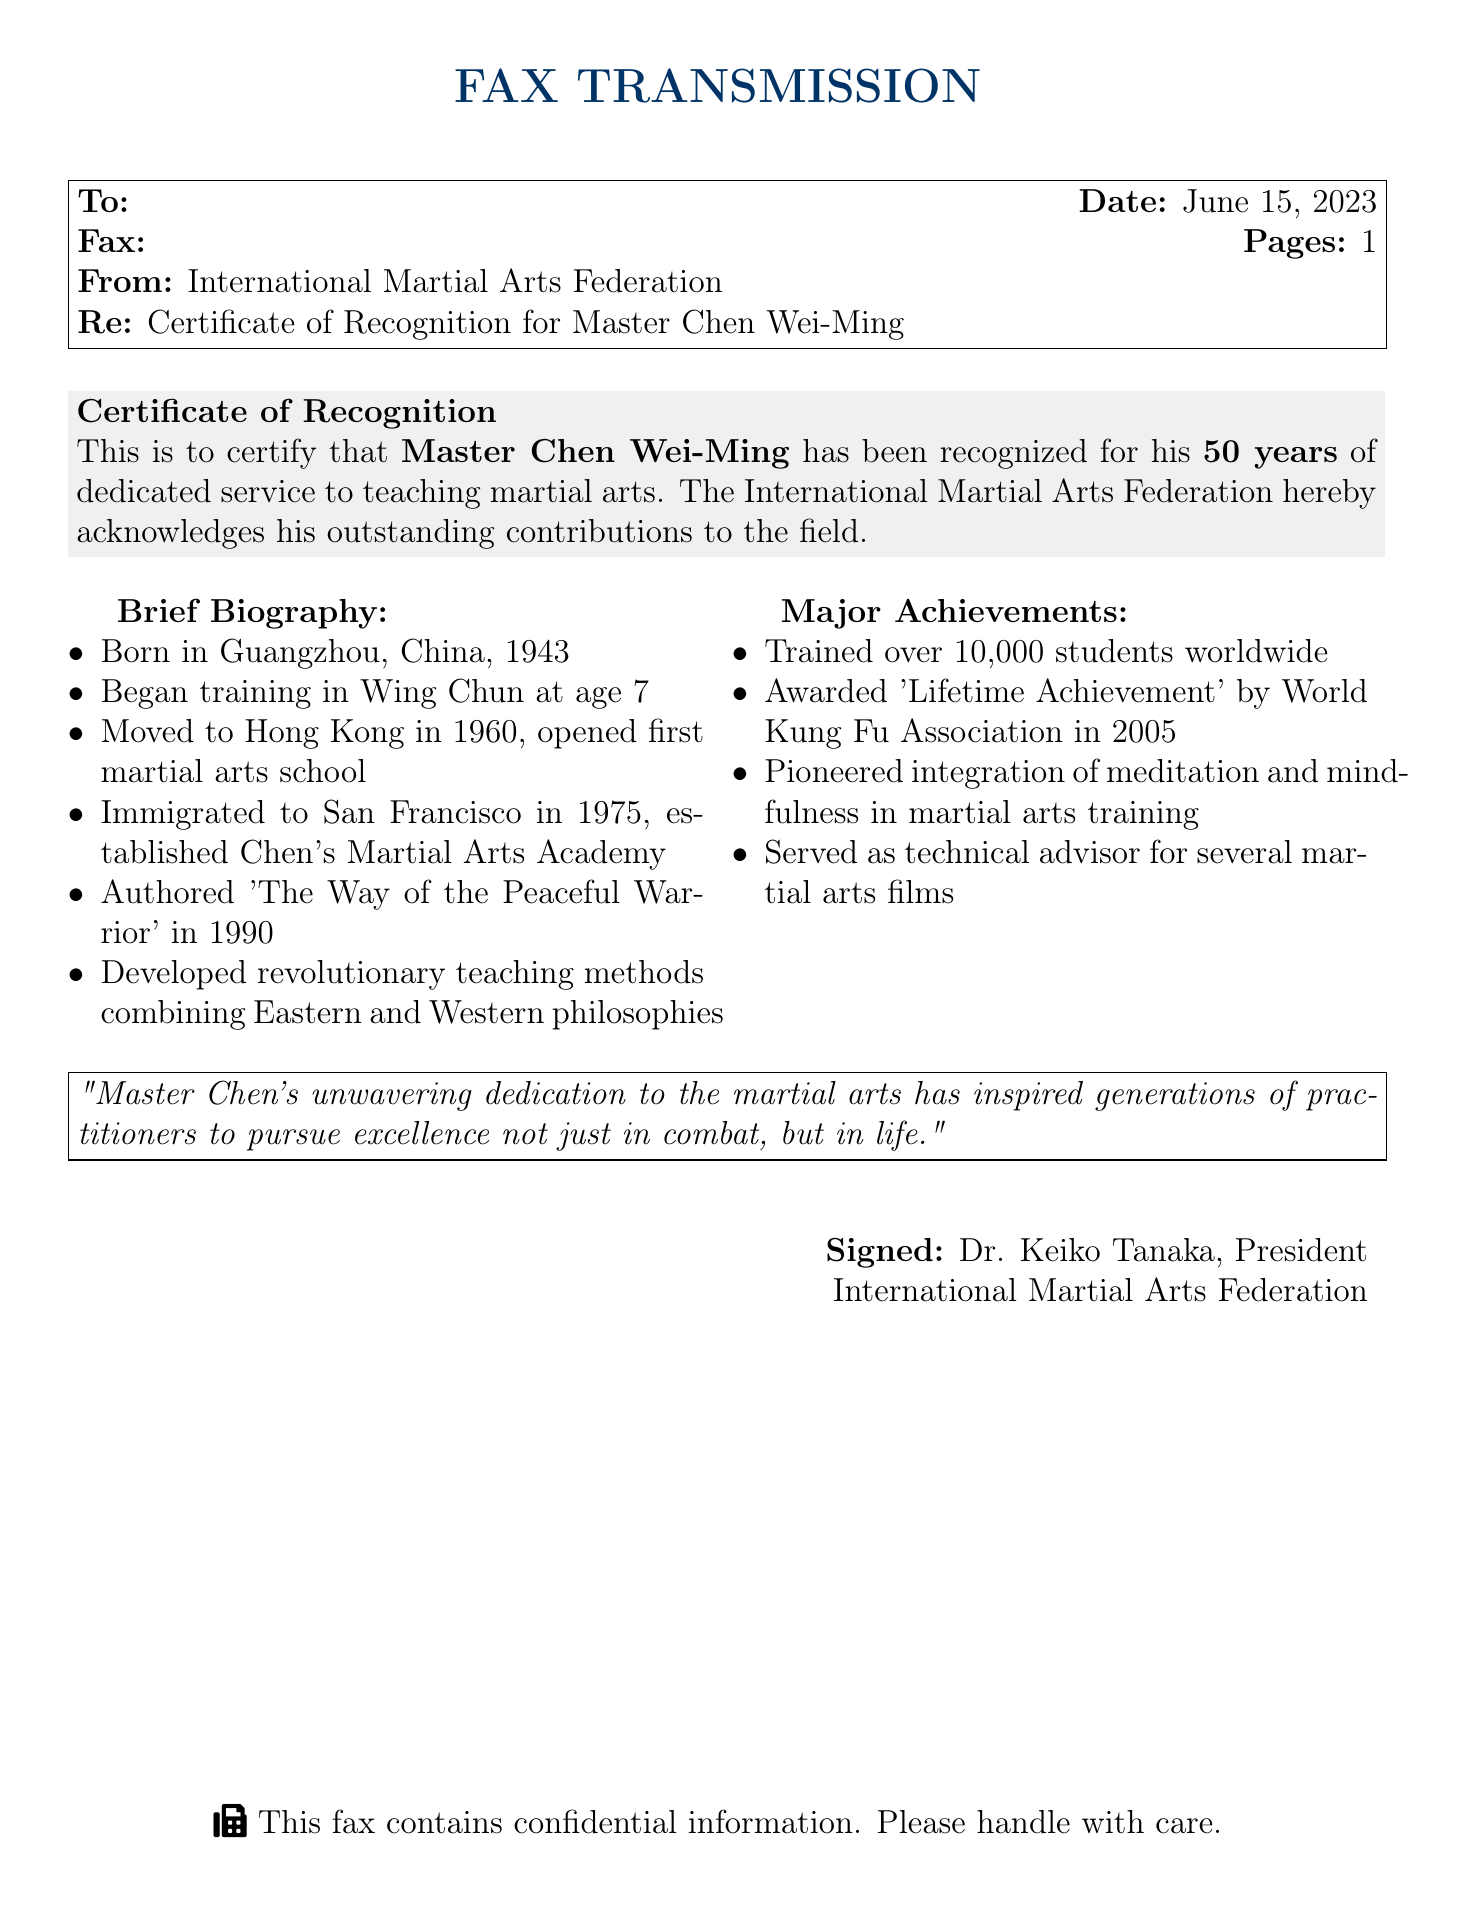What is the name of the individual recognized? The fax explicitly states that Master Chen Wei-Ming has been recognized.
Answer: Master Chen Wei-Ming What is the duration of service mentioned? The document highlights that the recognition is for 50 years of dedicated service.
Answer: 50 years In what year did Master Chen begin training? The biography indicates he started training in Wing Chun at age 7, with his birth year being 1943.
Answer: 1943 What notable work did Master Chen publish? The document states he authored 'The Way of the Peaceful Warrior' in 1990.
Answer: The Way of the Peaceful Warrior Which academy did Master Chen establish in San Francisco? The text notes that he established Chen's Martial Arts Academy upon immigrating to San Francisco.
Answer: Chen's Martial Arts Academy When was Master Chen awarded the 'Lifetime Achievement'? The document records that this award was given in 2005 by the World Kung Fu Association.
Answer: 2005 What unique teaching methods did Master Chen develop? The document states he combined Eastern and Western philosophies in his teaching methods.
Answer: Eastern and Western philosophies Who signed the certificate? The fax indicates that Dr. Keiko Tanaka, President, signed the document.
Answer: Dr. Keiko Tanaka How many students has Master Chen trained worldwide? The major achievements section mentions he trained over 10,000 students worldwide.
Answer: Over 10,000 students 